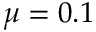Convert formula to latex. <formula><loc_0><loc_0><loc_500><loc_500>\mu = 0 . 1</formula> 